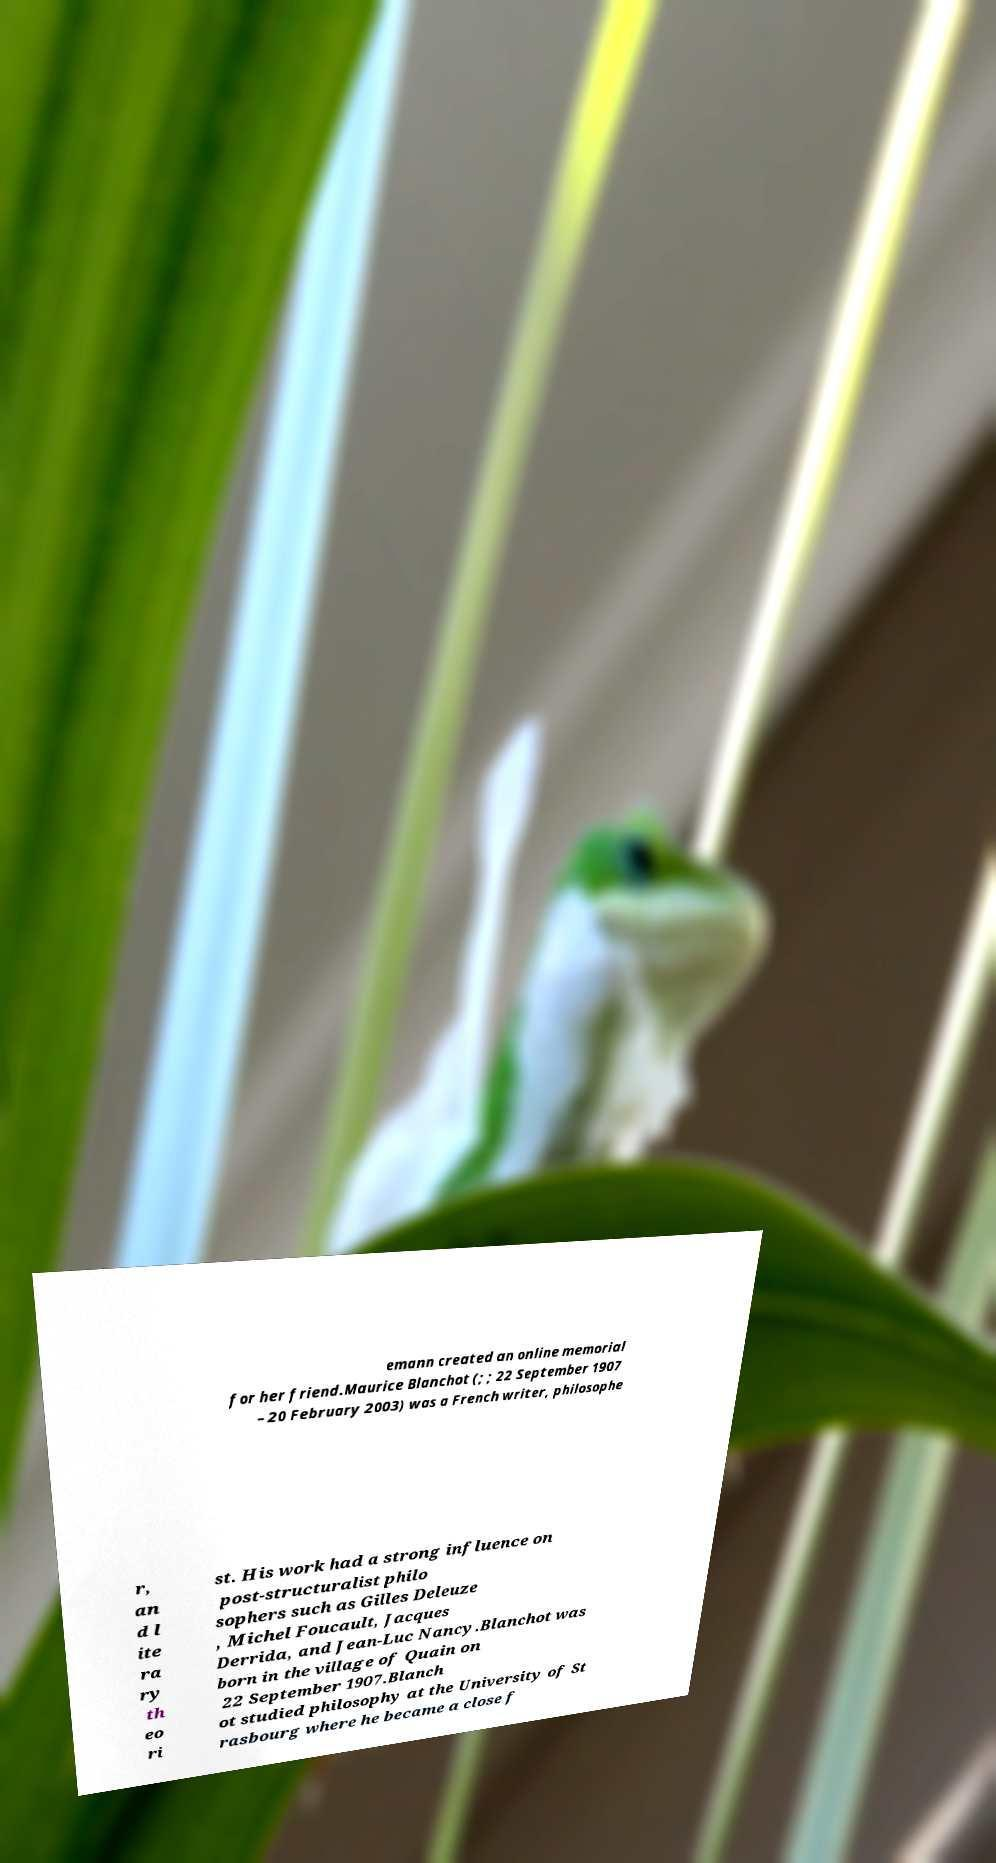What messages or text are displayed in this image? I need them in a readable, typed format. emann created an online memorial for her friend.Maurice Blanchot (; ; 22 September 1907 – 20 February 2003) was a French writer, philosophe r, an d l ite ra ry th eo ri st. His work had a strong influence on post-structuralist philo sophers such as Gilles Deleuze , Michel Foucault, Jacques Derrida, and Jean-Luc Nancy.Blanchot was born in the village of Quain on 22 September 1907.Blanch ot studied philosophy at the University of St rasbourg where he became a close f 